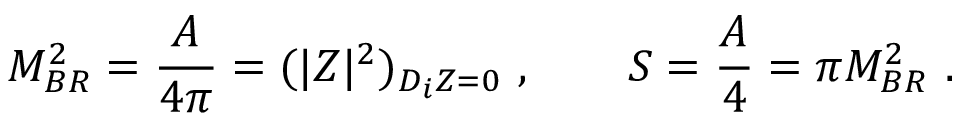Convert formula to latex. <formula><loc_0><loc_0><loc_500><loc_500>M _ { B R } ^ { 2 } = { \frac { A } { 4 \pi } } = ( | Z | ^ { 2 } ) _ { D _ { i } Z = 0 } \ , \quad S = { \frac { A } { 4 } } = \pi M _ { B R } ^ { 2 } \ .</formula> 